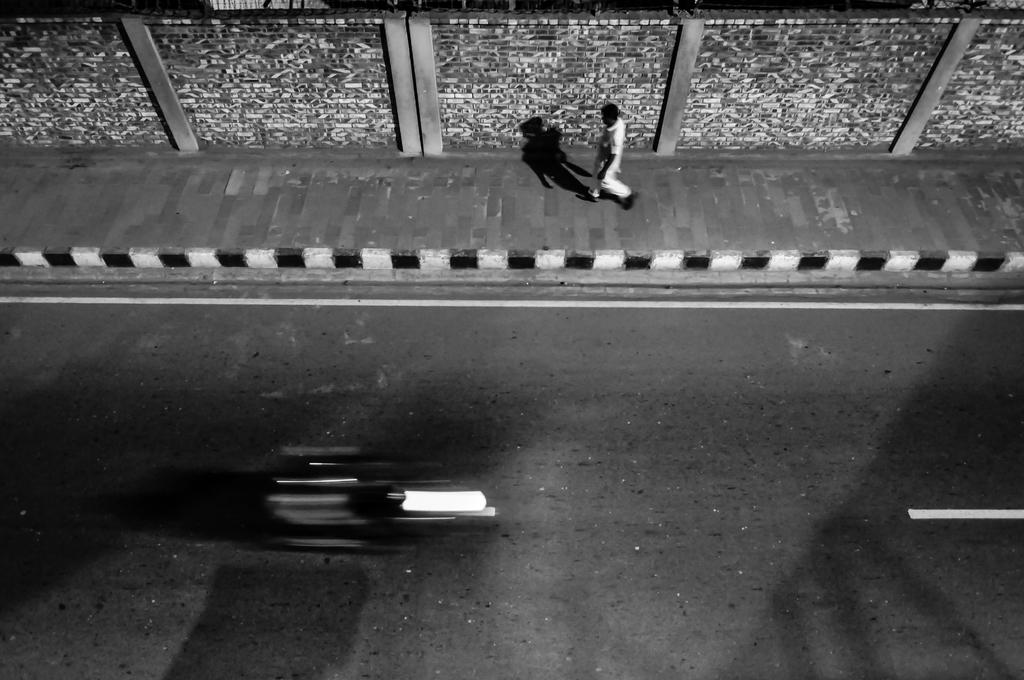Who is present in the image? There is a man in the image. What is the man doing in the image? The man is walking on a footpath. What can be seen at the top of the image? There is a wall at the top of the image. What is located at the bottom of the image? There is a road at the bottom of the image. What type of needle is being used to sew the cloth in the image? There is no needle or cloth present in the image; it features a man walking on a footpath with a wall at the top and a road at the bottom. 